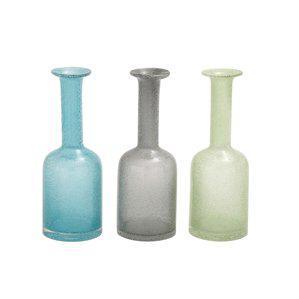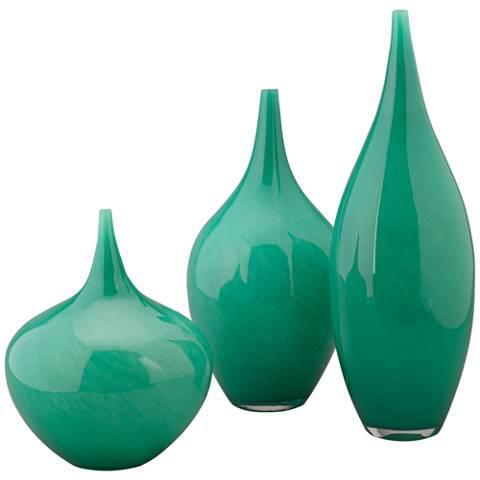The first image is the image on the left, the second image is the image on the right. Considering the images on both sides, is "Bottles in the left image share the same shape." valid? Answer yes or no. Yes. 